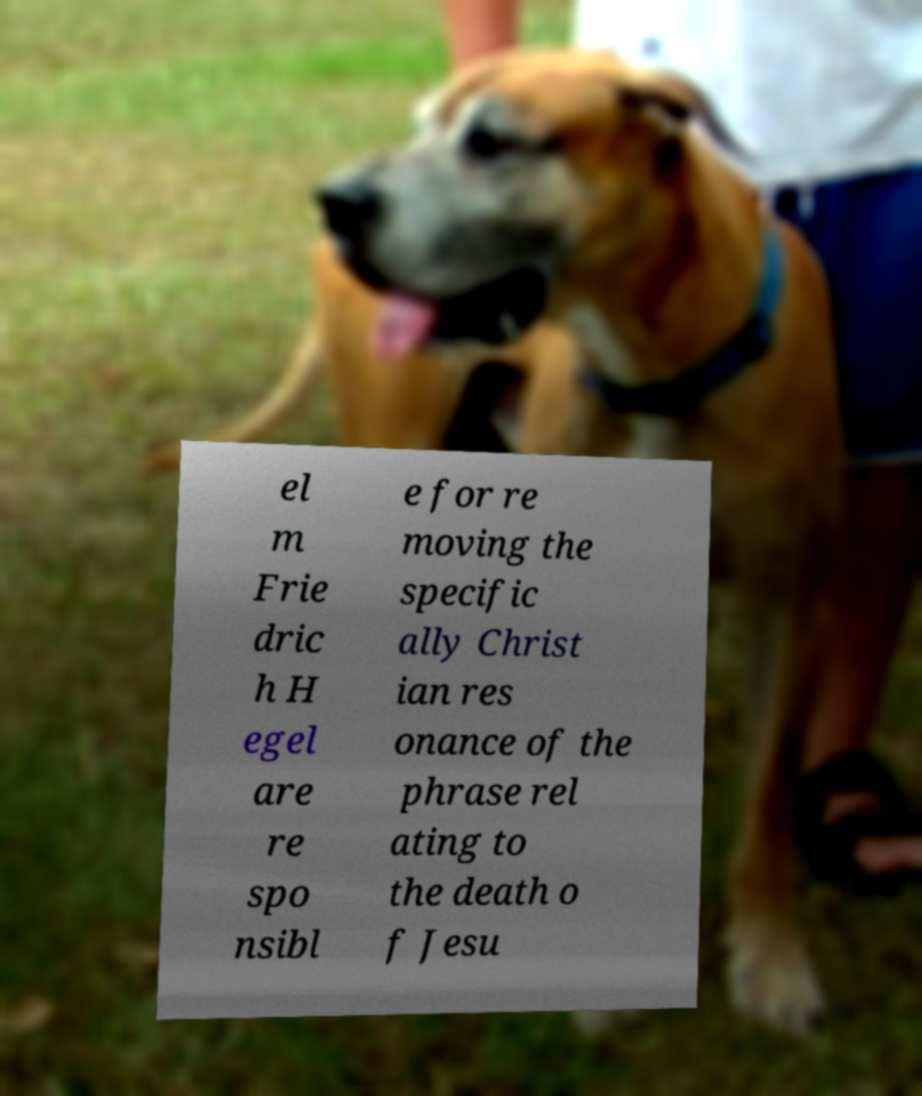Please read and relay the text visible in this image. What does it say? el m Frie dric h H egel are re spo nsibl e for re moving the specific ally Christ ian res onance of the phrase rel ating to the death o f Jesu 